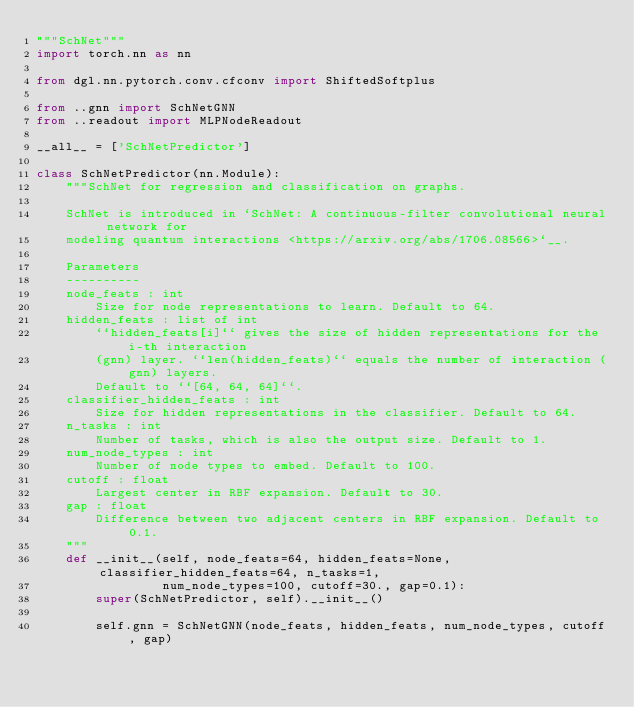<code> <loc_0><loc_0><loc_500><loc_500><_Python_>"""SchNet"""
import torch.nn as nn

from dgl.nn.pytorch.conv.cfconv import ShiftedSoftplus

from ..gnn import SchNetGNN
from ..readout import MLPNodeReadout

__all__ = ['SchNetPredictor']

class SchNetPredictor(nn.Module):
    """SchNet for regression and classification on graphs.

    SchNet is introduced in `SchNet: A continuous-filter convolutional neural network for
    modeling quantum interactions <https://arxiv.org/abs/1706.08566>`__.

    Parameters
    ----------
    node_feats : int
        Size for node representations to learn. Default to 64.
    hidden_feats : list of int
        ``hidden_feats[i]`` gives the size of hidden representations for the i-th interaction
        (gnn) layer. ``len(hidden_feats)`` equals the number of interaction (gnn) layers.
        Default to ``[64, 64, 64]``.
    classifier_hidden_feats : int
        Size for hidden representations in the classifier. Default to 64.
    n_tasks : int
        Number of tasks, which is also the output size. Default to 1.
    num_node_types : int
        Number of node types to embed. Default to 100.
    cutoff : float
        Largest center in RBF expansion. Default to 30.
    gap : float
        Difference between two adjacent centers in RBF expansion. Default to 0.1.
    """
    def __init__(self, node_feats=64, hidden_feats=None, classifier_hidden_feats=64, n_tasks=1,
                 num_node_types=100, cutoff=30., gap=0.1):
        super(SchNetPredictor, self).__init__()

        self.gnn = SchNetGNN(node_feats, hidden_feats, num_node_types, cutoff, gap)</code> 